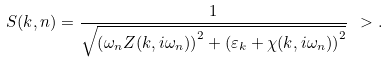Convert formula to latex. <formula><loc_0><loc_0><loc_500><loc_500>S ( { k } , n ) = \frac { 1 } { \sqrt { \left ( \omega _ { n } Z ( { k } , i \omega _ { n } ) \right ) ^ { 2 } + \left ( \varepsilon _ { k } + \chi ( { k } , i \omega _ { n } ) \right ) ^ { 2 } } } \ > .</formula> 